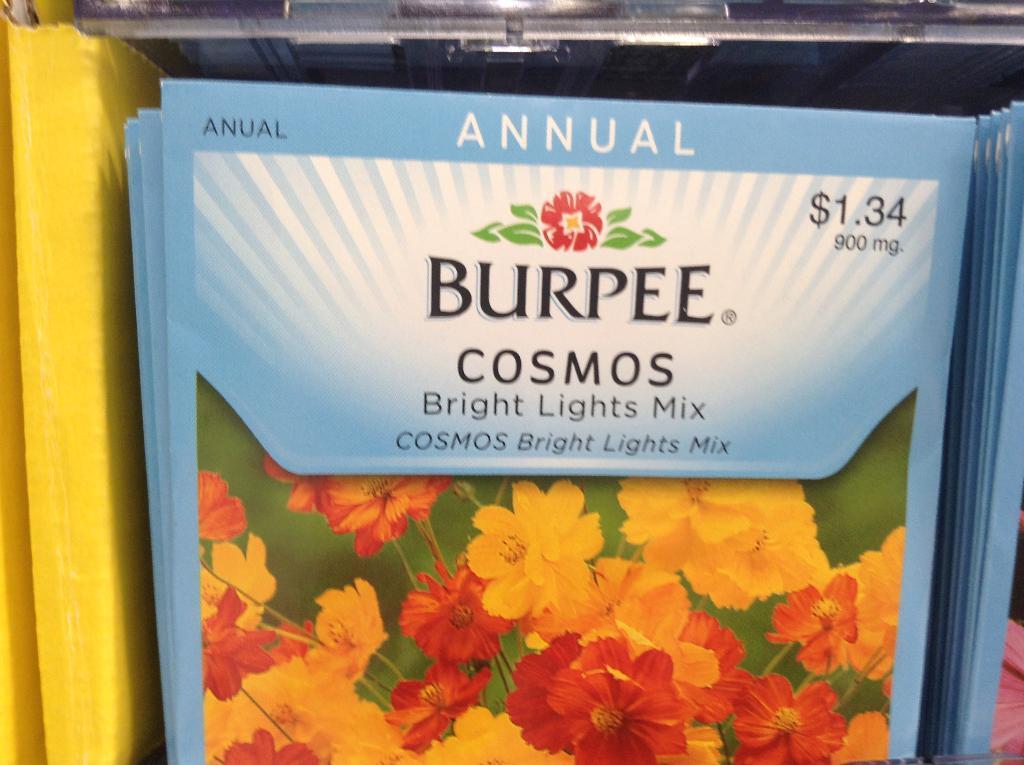How would you summarize this image in a sentence or two? In this image in the foreground all this look like a pamphlet and something is written on it. 